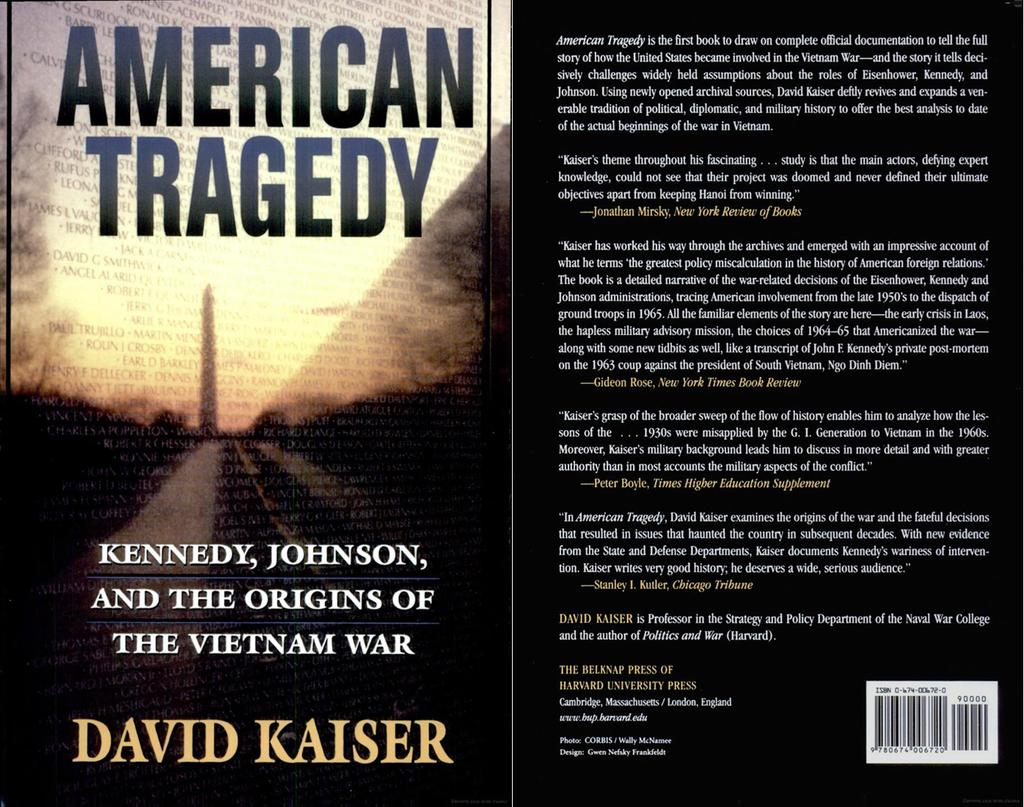Provide a one-sentence caption for the provided image. A book is displayed with the title of, "American Tragedy.". 